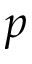Convert formula to latex. <formula><loc_0><loc_0><loc_500><loc_500>p</formula> 